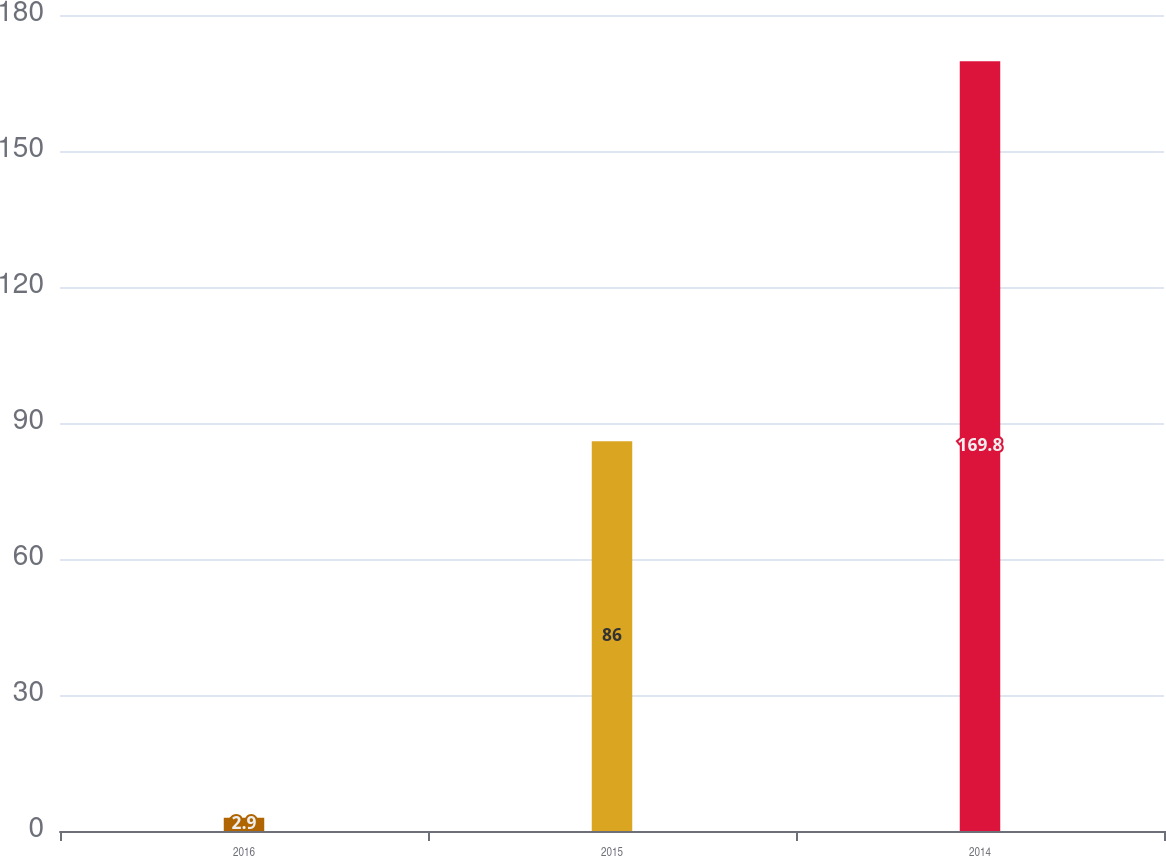<chart> <loc_0><loc_0><loc_500><loc_500><bar_chart><fcel>2016<fcel>2015<fcel>2014<nl><fcel>2.9<fcel>86<fcel>169.8<nl></chart> 